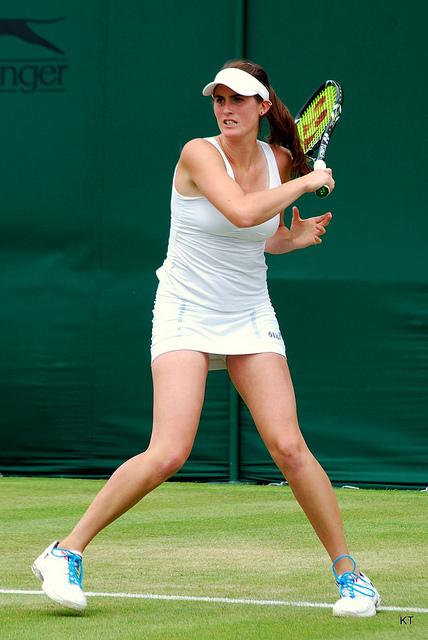How old is the woman?
Concise answer only. 20. Where are the blue shoe strings?
Be succinct. On her shoes. Does there outfit match the racket?
Keep it brief. No. Is the woman standing straight?
Concise answer only. No. 